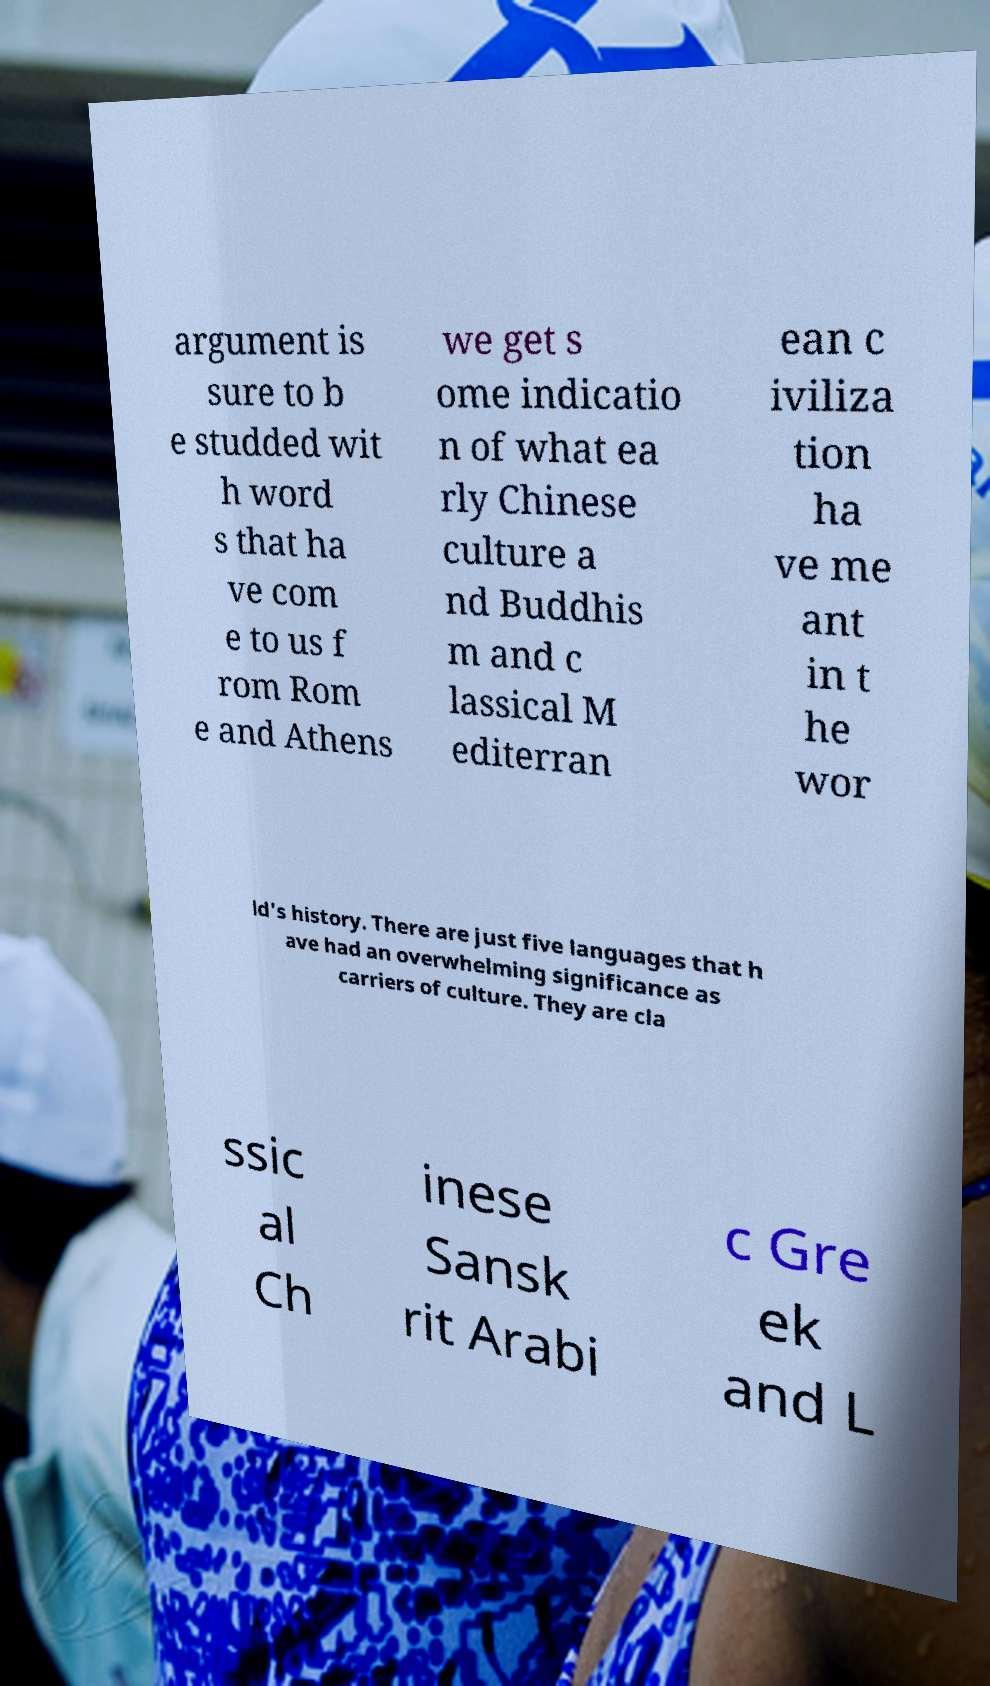For documentation purposes, I need the text within this image transcribed. Could you provide that? argument is sure to b e studded wit h word s that ha ve com e to us f rom Rom e and Athens we get s ome indicatio n of what ea rly Chinese culture a nd Buddhis m and c lassical M editerran ean c iviliza tion ha ve me ant in t he wor ld's history. There are just five languages that h ave had an overwhelming significance as carriers of culture. They are cla ssic al Ch inese Sansk rit Arabi c Gre ek and L 